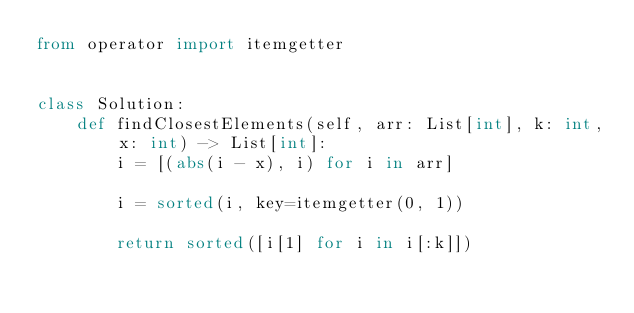Convert code to text. <code><loc_0><loc_0><loc_500><loc_500><_Python_>from operator import itemgetter


class Solution:
    def findClosestElements(self, arr: List[int], k: int, x: int) -> List[int]:
        i = [(abs(i - x), i) for i in arr]

        i = sorted(i, key=itemgetter(0, 1))

        return sorted([i[1] for i in i[:k]])

</code> 